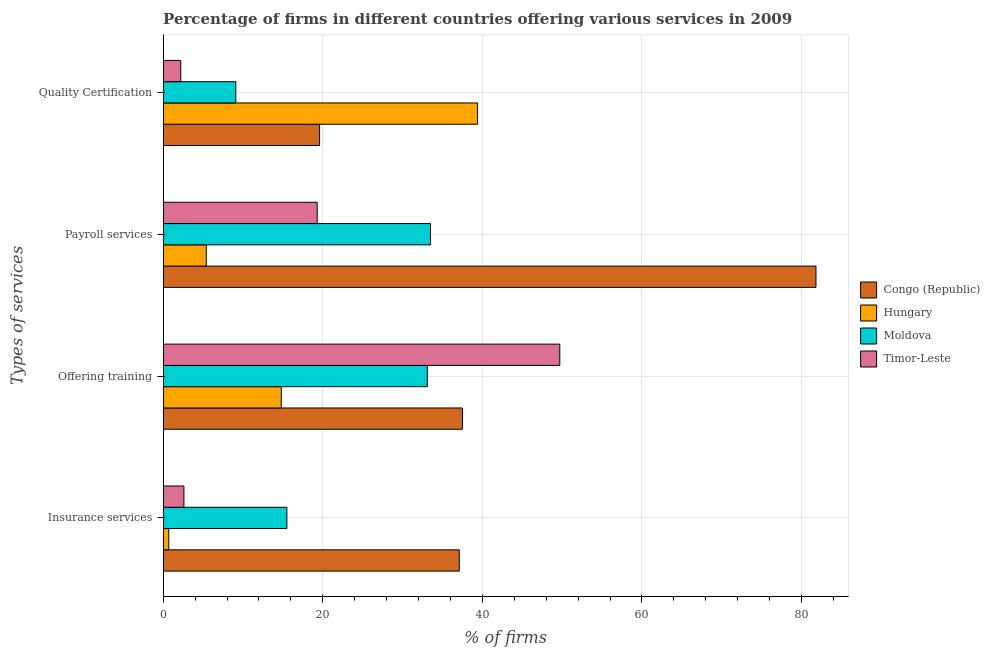How many different coloured bars are there?
Offer a very short reply. 4. Are the number of bars per tick equal to the number of legend labels?
Make the answer very short. Yes. Are the number of bars on each tick of the Y-axis equal?
Your response must be concise. Yes. How many bars are there on the 3rd tick from the bottom?
Provide a succinct answer. 4. What is the label of the 4th group of bars from the top?
Ensure brevity in your answer.  Insurance services. What is the percentage of firms offering payroll services in Hungary?
Ensure brevity in your answer.  5.4. Across all countries, what is the maximum percentage of firms offering insurance services?
Your answer should be compact. 37.1. Across all countries, what is the minimum percentage of firms offering payroll services?
Offer a terse response. 5.4. In which country was the percentage of firms offering payroll services maximum?
Provide a succinct answer. Congo (Republic). In which country was the percentage of firms offering insurance services minimum?
Offer a very short reply. Hungary. What is the total percentage of firms offering insurance services in the graph?
Your response must be concise. 55.9. What is the difference between the percentage of firms offering quality certification in Timor-Leste and that in Congo (Republic)?
Offer a terse response. -17.4. What is the difference between the percentage of firms offering quality certification in Moldova and the percentage of firms offering payroll services in Congo (Republic)?
Your answer should be compact. -72.7. What is the average percentage of firms offering insurance services per country?
Provide a succinct answer. 13.98. What is the ratio of the percentage of firms offering training in Timor-Leste to that in Moldova?
Give a very brief answer. 1.5. Is the difference between the percentage of firms offering insurance services in Hungary and Moldova greater than the difference between the percentage of firms offering training in Hungary and Moldova?
Your answer should be very brief. Yes. What is the difference between the highest and the second highest percentage of firms offering quality certification?
Make the answer very short. 19.8. What is the difference between the highest and the lowest percentage of firms offering training?
Give a very brief answer. 34.9. In how many countries, is the percentage of firms offering payroll services greater than the average percentage of firms offering payroll services taken over all countries?
Make the answer very short. 1. Is the sum of the percentage of firms offering training in Timor-Leste and Moldova greater than the maximum percentage of firms offering quality certification across all countries?
Provide a short and direct response. Yes. Is it the case that in every country, the sum of the percentage of firms offering quality certification and percentage of firms offering payroll services is greater than the sum of percentage of firms offering training and percentage of firms offering insurance services?
Offer a very short reply. No. What does the 2nd bar from the top in Payroll services represents?
Offer a terse response. Moldova. What does the 3rd bar from the bottom in Quality Certification represents?
Make the answer very short. Moldova. Is it the case that in every country, the sum of the percentage of firms offering insurance services and percentage of firms offering training is greater than the percentage of firms offering payroll services?
Your answer should be very brief. No. How many bars are there?
Make the answer very short. 16. How many countries are there in the graph?
Ensure brevity in your answer.  4. Does the graph contain grids?
Make the answer very short. Yes. How many legend labels are there?
Offer a very short reply. 4. What is the title of the graph?
Your response must be concise. Percentage of firms in different countries offering various services in 2009. What is the label or title of the X-axis?
Your answer should be compact. % of firms. What is the label or title of the Y-axis?
Your answer should be very brief. Types of services. What is the % of firms of Congo (Republic) in Insurance services?
Give a very brief answer. 37.1. What is the % of firms in Hungary in Insurance services?
Make the answer very short. 0.7. What is the % of firms in Moldova in Insurance services?
Give a very brief answer. 15.5. What is the % of firms of Timor-Leste in Insurance services?
Your answer should be very brief. 2.6. What is the % of firms in Congo (Republic) in Offering training?
Ensure brevity in your answer.  37.5. What is the % of firms in Hungary in Offering training?
Give a very brief answer. 14.8. What is the % of firms in Moldova in Offering training?
Offer a very short reply. 33.1. What is the % of firms in Timor-Leste in Offering training?
Make the answer very short. 49.7. What is the % of firms in Congo (Republic) in Payroll services?
Offer a very short reply. 81.8. What is the % of firms in Hungary in Payroll services?
Your response must be concise. 5.4. What is the % of firms in Moldova in Payroll services?
Your answer should be compact. 33.5. What is the % of firms in Timor-Leste in Payroll services?
Make the answer very short. 19.3. What is the % of firms of Congo (Republic) in Quality Certification?
Your answer should be very brief. 19.6. What is the % of firms of Hungary in Quality Certification?
Offer a terse response. 39.4. What is the % of firms of Moldova in Quality Certification?
Your response must be concise. 9.1. Across all Types of services, what is the maximum % of firms in Congo (Republic)?
Make the answer very short. 81.8. Across all Types of services, what is the maximum % of firms in Hungary?
Your answer should be compact. 39.4. Across all Types of services, what is the maximum % of firms of Moldova?
Offer a very short reply. 33.5. Across all Types of services, what is the maximum % of firms of Timor-Leste?
Provide a succinct answer. 49.7. Across all Types of services, what is the minimum % of firms of Congo (Republic)?
Offer a very short reply. 19.6. Across all Types of services, what is the minimum % of firms of Moldova?
Your answer should be compact. 9.1. Across all Types of services, what is the minimum % of firms of Timor-Leste?
Ensure brevity in your answer.  2.2. What is the total % of firms of Congo (Republic) in the graph?
Your answer should be compact. 176. What is the total % of firms of Hungary in the graph?
Give a very brief answer. 60.3. What is the total % of firms of Moldova in the graph?
Give a very brief answer. 91.2. What is the total % of firms in Timor-Leste in the graph?
Make the answer very short. 73.8. What is the difference between the % of firms in Hungary in Insurance services and that in Offering training?
Keep it short and to the point. -14.1. What is the difference between the % of firms of Moldova in Insurance services and that in Offering training?
Provide a short and direct response. -17.6. What is the difference between the % of firms in Timor-Leste in Insurance services and that in Offering training?
Give a very brief answer. -47.1. What is the difference between the % of firms of Congo (Republic) in Insurance services and that in Payroll services?
Your answer should be very brief. -44.7. What is the difference between the % of firms in Hungary in Insurance services and that in Payroll services?
Offer a terse response. -4.7. What is the difference between the % of firms of Timor-Leste in Insurance services and that in Payroll services?
Ensure brevity in your answer.  -16.7. What is the difference between the % of firms in Congo (Republic) in Insurance services and that in Quality Certification?
Keep it short and to the point. 17.5. What is the difference between the % of firms in Hungary in Insurance services and that in Quality Certification?
Ensure brevity in your answer.  -38.7. What is the difference between the % of firms of Congo (Republic) in Offering training and that in Payroll services?
Offer a very short reply. -44.3. What is the difference between the % of firms of Moldova in Offering training and that in Payroll services?
Your answer should be compact. -0.4. What is the difference between the % of firms in Timor-Leste in Offering training and that in Payroll services?
Offer a terse response. 30.4. What is the difference between the % of firms of Congo (Republic) in Offering training and that in Quality Certification?
Provide a succinct answer. 17.9. What is the difference between the % of firms in Hungary in Offering training and that in Quality Certification?
Ensure brevity in your answer.  -24.6. What is the difference between the % of firms in Timor-Leste in Offering training and that in Quality Certification?
Provide a short and direct response. 47.5. What is the difference between the % of firms of Congo (Republic) in Payroll services and that in Quality Certification?
Provide a short and direct response. 62.2. What is the difference between the % of firms of Hungary in Payroll services and that in Quality Certification?
Make the answer very short. -34. What is the difference between the % of firms in Moldova in Payroll services and that in Quality Certification?
Provide a succinct answer. 24.4. What is the difference between the % of firms of Congo (Republic) in Insurance services and the % of firms of Hungary in Offering training?
Your response must be concise. 22.3. What is the difference between the % of firms of Hungary in Insurance services and the % of firms of Moldova in Offering training?
Give a very brief answer. -32.4. What is the difference between the % of firms in Hungary in Insurance services and the % of firms in Timor-Leste in Offering training?
Your response must be concise. -49. What is the difference between the % of firms in Moldova in Insurance services and the % of firms in Timor-Leste in Offering training?
Ensure brevity in your answer.  -34.2. What is the difference between the % of firms of Congo (Republic) in Insurance services and the % of firms of Hungary in Payroll services?
Make the answer very short. 31.7. What is the difference between the % of firms in Congo (Republic) in Insurance services and the % of firms in Moldova in Payroll services?
Your answer should be very brief. 3.6. What is the difference between the % of firms of Hungary in Insurance services and the % of firms of Moldova in Payroll services?
Give a very brief answer. -32.8. What is the difference between the % of firms of Hungary in Insurance services and the % of firms of Timor-Leste in Payroll services?
Provide a succinct answer. -18.6. What is the difference between the % of firms in Moldova in Insurance services and the % of firms in Timor-Leste in Payroll services?
Provide a short and direct response. -3.8. What is the difference between the % of firms in Congo (Republic) in Insurance services and the % of firms in Moldova in Quality Certification?
Your answer should be compact. 28. What is the difference between the % of firms of Congo (Republic) in Insurance services and the % of firms of Timor-Leste in Quality Certification?
Your answer should be very brief. 34.9. What is the difference between the % of firms in Moldova in Insurance services and the % of firms in Timor-Leste in Quality Certification?
Provide a succinct answer. 13.3. What is the difference between the % of firms in Congo (Republic) in Offering training and the % of firms in Hungary in Payroll services?
Offer a very short reply. 32.1. What is the difference between the % of firms in Congo (Republic) in Offering training and the % of firms in Moldova in Payroll services?
Provide a succinct answer. 4. What is the difference between the % of firms of Congo (Republic) in Offering training and the % of firms of Timor-Leste in Payroll services?
Ensure brevity in your answer.  18.2. What is the difference between the % of firms in Hungary in Offering training and the % of firms in Moldova in Payroll services?
Your answer should be compact. -18.7. What is the difference between the % of firms in Hungary in Offering training and the % of firms in Timor-Leste in Payroll services?
Keep it short and to the point. -4.5. What is the difference between the % of firms of Moldova in Offering training and the % of firms of Timor-Leste in Payroll services?
Provide a short and direct response. 13.8. What is the difference between the % of firms in Congo (Republic) in Offering training and the % of firms in Hungary in Quality Certification?
Give a very brief answer. -1.9. What is the difference between the % of firms in Congo (Republic) in Offering training and the % of firms in Moldova in Quality Certification?
Give a very brief answer. 28.4. What is the difference between the % of firms of Congo (Republic) in Offering training and the % of firms of Timor-Leste in Quality Certification?
Give a very brief answer. 35.3. What is the difference between the % of firms in Hungary in Offering training and the % of firms in Timor-Leste in Quality Certification?
Provide a succinct answer. 12.6. What is the difference between the % of firms in Moldova in Offering training and the % of firms in Timor-Leste in Quality Certification?
Your response must be concise. 30.9. What is the difference between the % of firms of Congo (Republic) in Payroll services and the % of firms of Hungary in Quality Certification?
Provide a succinct answer. 42.4. What is the difference between the % of firms of Congo (Republic) in Payroll services and the % of firms of Moldova in Quality Certification?
Your response must be concise. 72.7. What is the difference between the % of firms of Congo (Republic) in Payroll services and the % of firms of Timor-Leste in Quality Certification?
Provide a short and direct response. 79.6. What is the difference between the % of firms in Hungary in Payroll services and the % of firms in Moldova in Quality Certification?
Your answer should be very brief. -3.7. What is the difference between the % of firms of Moldova in Payroll services and the % of firms of Timor-Leste in Quality Certification?
Keep it short and to the point. 31.3. What is the average % of firms of Congo (Republic) per Types of services?
Keep it short and to the point. 44. What is the average % of firms in Hungary per Types of services?
Keep it short and to the point. 15.07. What is the average % of firms in Moldova per Types of services?
Give a very brief answer. 22.8. What is the average % of firms in Timor-Leste per Types of services?
Give a very brief answer. 18.45. What is the difference between the % of firms of Congo (Republic) and % of firms of Hungary in Insurance services?
Offer a terse response. 36.4. What is the difference between the % of firms in Congo (Republic) and % of firms in Moldova in Insurance services?
Provide a short and direct response. 21.6. What is the difference between the % of firms of Congo (Republic) and % of firms of Timor-Leste in Insurance services?
Provide a short and direct response. 34.5. What is the difference between the % of firms of Hungary and % of firms of Moldova in Insurance services?
Your response must be concise. -14.8. What is the difference between the % of firms of Moldova and % of firms of Timor-Leste in Insurance services?
Your answer should be very brief. 12.9. What is the difference between the % of firms in Congo (Republic) and % of firms in Hungary in Offering training?
Ensure brevity in your answer.  22.7. What is the difference between the % of firms in Congo (Republic) and % of firms in Timor-Leste in Offering training?
Your answer should be very brief. -12.2. What is the difference between the % of firms of Hungary and % of firms of Moldova in Offering training?
Your answer should be compact. -18.3. What is the difference between the % of firms in Hungary and % of firms in Timor-Leste in Offering training?
Your answer should be compact. -34.9. What is the difference between the % of firms of Moldova and % of firms of Timor-Leste in Offering training?
Your answer should be very brief. -16.6. What is the difference between the % of firms of Congo (Republic) and % of firms of Hungary in Payroll services?
Your answer should be very brief. 76.4. What is the difference between the % of firms in Congo (Republic) and % of firms in Moldova in Payroll services?
Ensure brevity in your answer.  48.3. What is the difference between the % of firms of Congo (Republic) and % of firms of Timor-Leste in Payroll services?
Your response must be concise. 62.5. What is the difference between the % of firms in Hungary and % of firms in Moldova in Payroll services?
Ensure brevity in your answer.  -28.1. What is the difference between the % of firms in Hungary and % of firms in Timor-Leste in Payroll services?
Give a very brief answer. -13.9. What is the difference between the % of firms in Moldova and % of firms in Timor-Leste in Payroll services?
Offer a terse response. 14.2. What is the difference between the % of firms of Congo (Republic) and % of firms of Hungary in Quality Certification?
Your answer should be very brief. -19.8. What is the difference between the % of firms in Hungary and % of firms in Moldova in Quality Certification?
Your answer should be very brief. 30.3. What is the difference between the % of firms of Hungary and % of firms of Timor-Leste in Quality Certification?
Give a very brief answer. 37.2. What is the difference between the % of firms in Moldova and % of firms in Timor-Leste in Quality Certification?
Offer a very short reply. 6.9. What is the ratio of the % of firms of Congo (Republic) in Insurance services to that in Offering training?
Give a very brief answer. 0.99. What is the ratio of the % of firms in Hungary in Insurance services to that in Offering training?
Make the answer very short. 0.05. What is the ratio of the % of firms of Moldova in Insurance services to that in Offering training?
Your answer should be compact. 0.47. What is the ratio of the % of firms of Timor-Leste in Insurance services to that in Offering training?
Keep it short and to the point. 0.05. What is the ratio of the % of firms of Congo (Republic) in Insurance services to that in Payroll services?
Ensure brevity in your answer.  0.45. What is the ratio of the % of firms of Hungary in Insurance services to that in Payroll services?
Your response must be concise. 0.13. What is the ratio of the % of firms of Moldova in Insurance services to that in Payroll services?
Your answer should be very brief. 0.46. What is the ratio of the % of firms in Timor-Leste in Insurance services to that in Payroll services?
Make the answer very short. 0.13. What is the ratio of the % of firms in Congo (Republic) in Insurance services to that in Quality Certification?
Keep it short and to the point. 1.89. What is the ratio of the % of firms in Hungary in Insurance services to that in Quality Certification?
Give a very brief answer. 0.02. What is the ratio of the % of firms of Moldova in Insurance services to that in Quality Certification?
Your response must be concise. 1.7. What is the ratio of the % of firms of Timor-Leste in Insurance services to that in Quality Certification?
Make the answer very short. 1.18. What is the ratio of the % of firms of Congo (Republic) in Offering training to that in Payroll services?
Your response must be concise. 0.46. What is the ratio of the % of firms in Hungary in Offering training to that in Payroll services?
Your response must be concise. 2.74. What is the ratio of the % of firms in Timor-Leste in Offering training to that in Payroll services?
Offer a very short reply. 2.58. What is the ratio of the % of firms in Congo (Republic) in Offering training to that in Quality Certification?
Provide a succinct answer. 1.91. What is the ratio of the % of firms in Hungary in Offering training to that in Quality Certification?
Ensure brevity in your answer.  0.38. What is the ratio of the % of firms in Moldova in Offering training to that in Quality Certification?
Give a very brief answer. 3.64. What is the ratio of the % of firms in Timor-Leste in Offering training to that in Quality Certification?
Your answer should be compact. 22.59. What is the ratio of the % of firms in Congo (Republic) in Payroll services to that in Quality Certification?
Your answer should be very brief. 4.17. What is the ratio of the % of firms of Hungary in Payroll services to that in Quality Certification?
Your response must be concise. 0.14. What is the ratio of the % of firms in Moldova in Payroll services to that in Quality Certification?
Give a very brief answer. 3.68. What is the ratio of the % of firms of Timor-Leste in Payroll services to that in Quality Certification?
Ensure brevity in your answer.  8.77. What is the difference between the highest and the second highest % of firms of Congo (Republic)?
Ensure brevity in your answer.  44.3. What is the difference between the highest and the second highest % of firms of Hungary?
Ensure brevity in your answer.  24.6. What is the difference between the highest and the second highest % of firms in Moldova?
Offer a very short reply. 0.4. What is the difference between the highest and the second highest % of firms in Timor-Leste?
Offer a terse response. 30.4. What is the difference between the highest and the lowest % of firms in Congo (Republic)?
Offer a very short reply. 62.2. What is the difference between the highest and the lowest % of firms of Hungary?
Make the answer very short. 38.7. What is the difference between the highest and the lowest % of firms of Moldova?
Make the answer very short. 24.4. What is the difference between the highest and the lowest % of firms in Timor-Leste?
Provide a short and direct response. 47.5. 